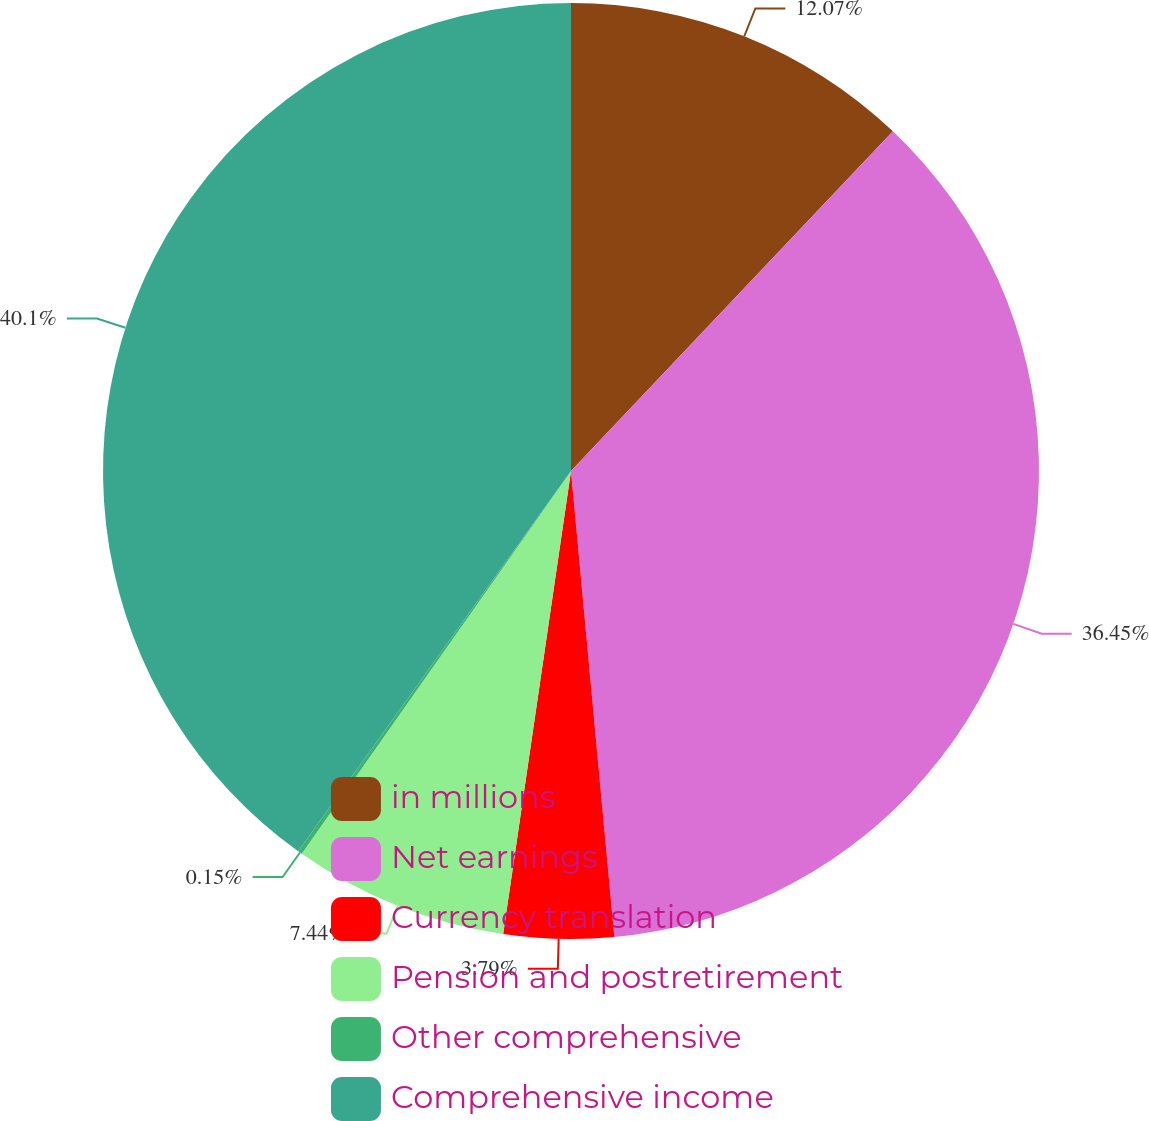Convert chart to OTSL. <chart><loc_0><loc_0><loc_500><loc_500><pie_chart><fcel>in millions<fcel>Net earnings<fcel>Currency translation<fcel>Pension and postretirement<fcel>Other comprehensive<fcel>Comprehensive income<nl><fcel>12.07%<fcel>36.45%<fcel>3.79%<fcel>7.44%<fcel>0.15%<fcel>40.09%<nl></chart> 